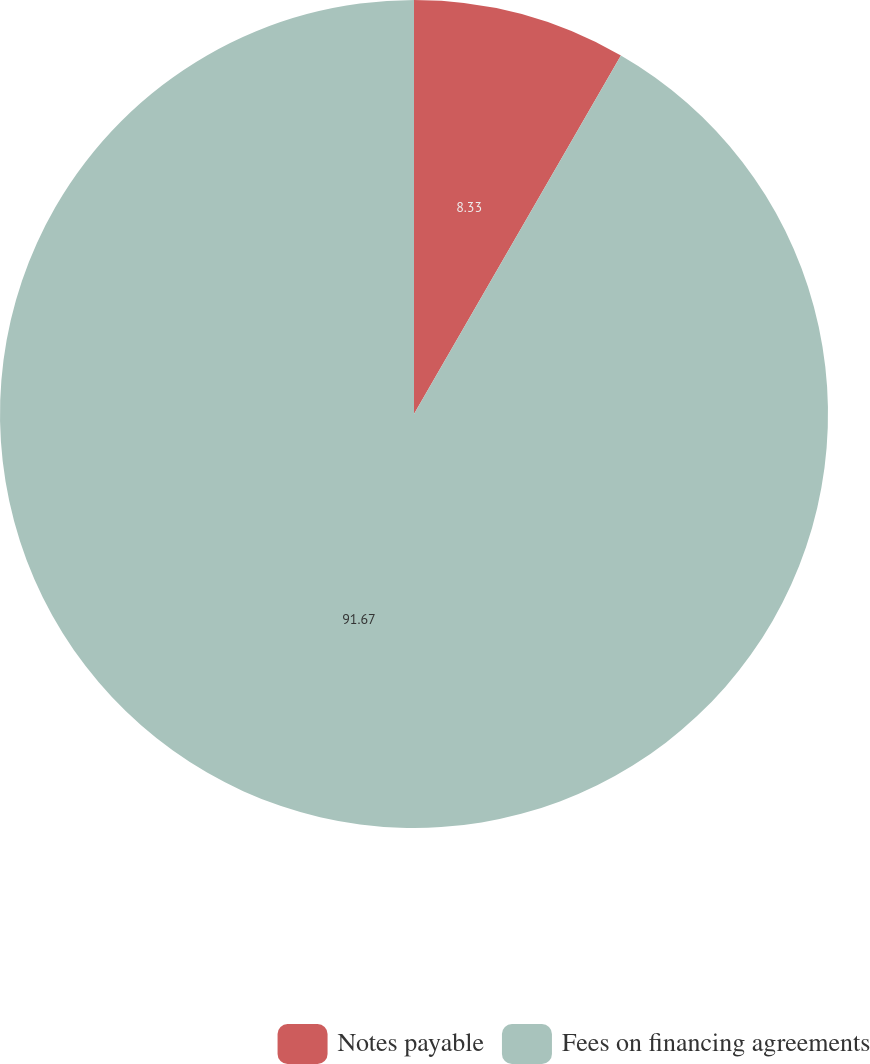Convert chart. <chart><loc_0><loc_0><loc_500><loc_500><pie_chart><fcel>Notes payable<fcel>Fees on financing agreements<nl><fcel>8.33%<fcel>91.67%<nl></chart> 